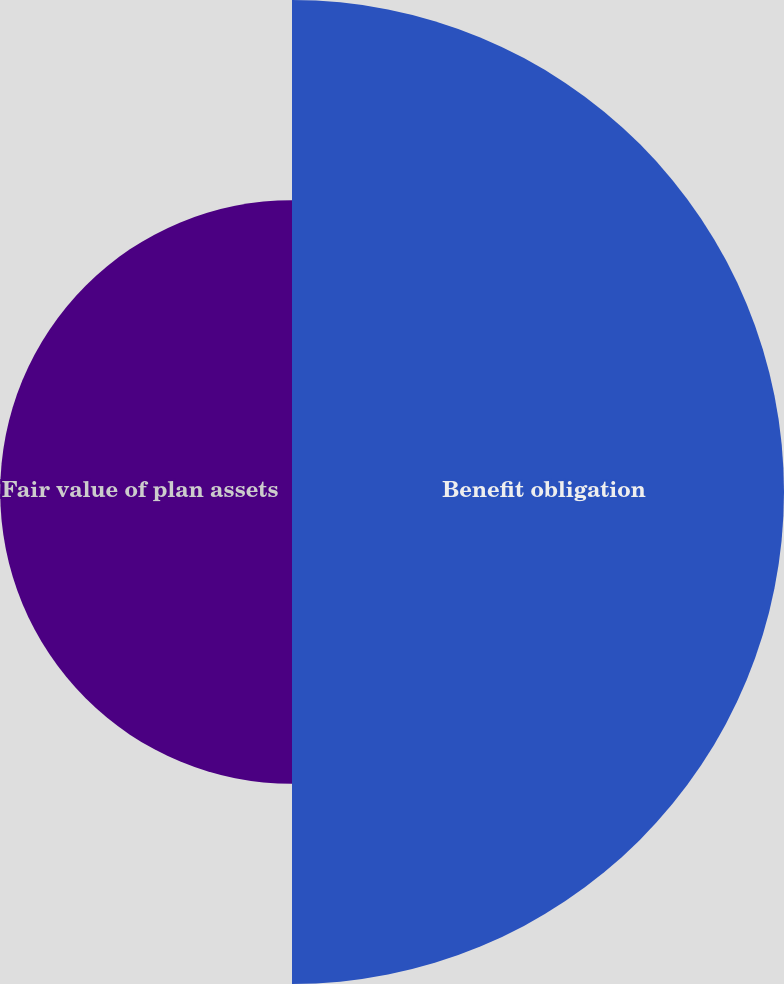Convert chart. <chart><loc_0><loc_0><loc_500><loc_500><pie_chart><fcel>Benefit obligation<fcel>Fair value of plan assets<nl><fcel>62.77%<fcel>37.23%<nl></chart> 